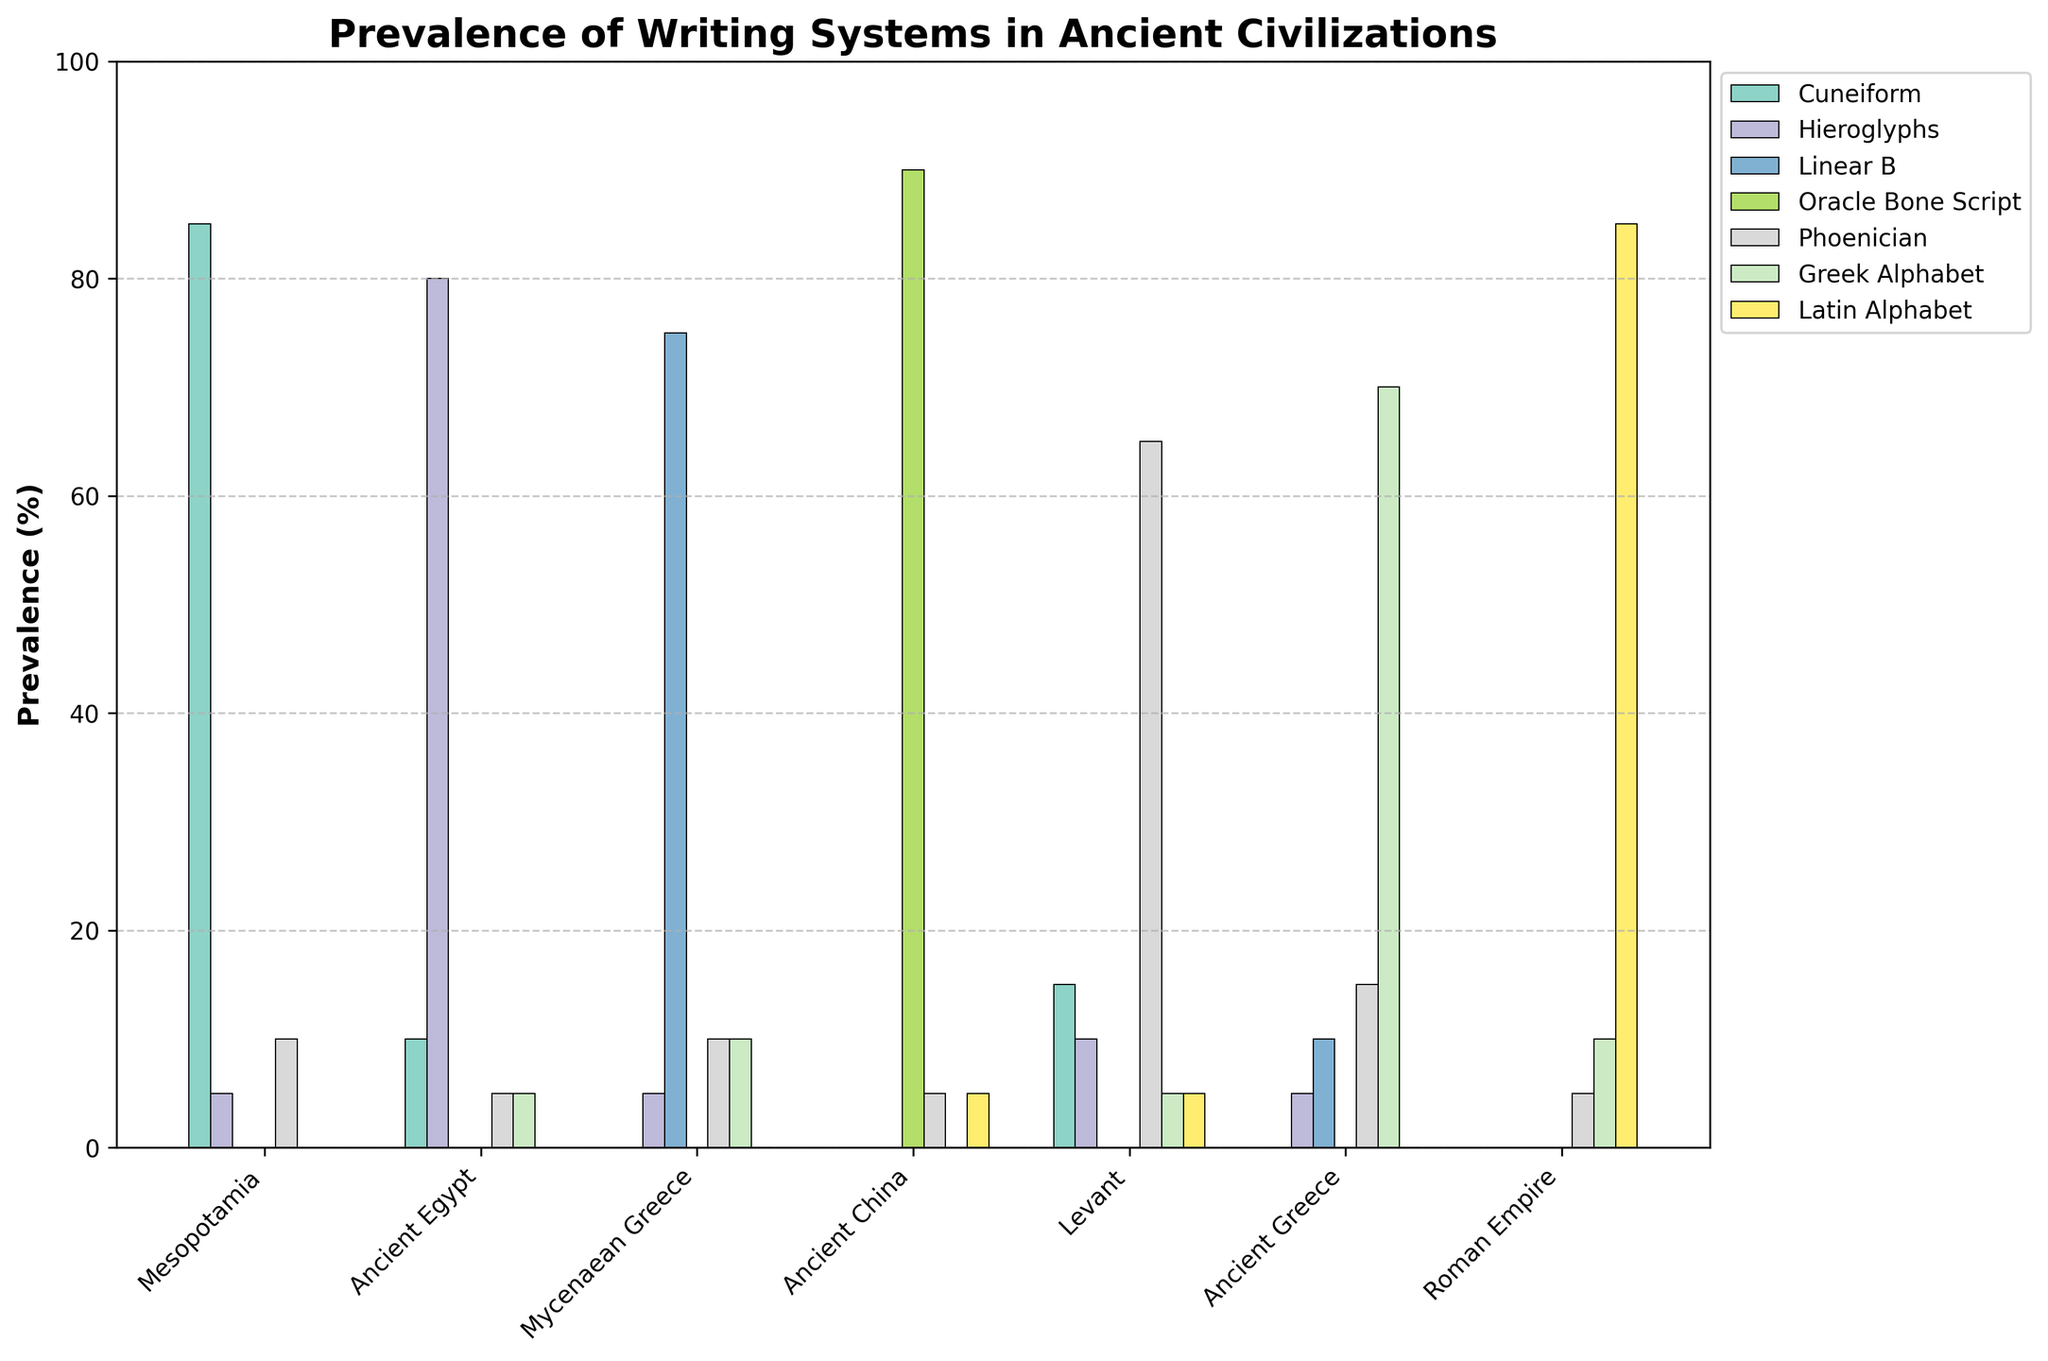What's the most prevalent writing system in Ancient Egypt? The figure shows the prevalence of various writing systems in Ancient Egypt by the height and color of the bars. The tallest bar for Ancient Egypt, which represents the highest prevalence, is Hieroglyphs.
Answer: Hieroglyphs Which regions have shared the use of the Greek Alphabet? The figure indicates the prevalence of writing systems by color-coded bars. The Greek Alphabet is used in Ancient Egypt, Mycenaean Greece, Ancient Greece, and the Roman Empire, as indicated by colored bars for these regions.
Answer: Ancient Egypt, Mycenaean Greece, Ancient Greece, Roman Empire What is the combined prevalence of Cuneiform and Phoenician in Mesopotamia? In the figure, the Cuneiform prevalence in Mesopotamia is 85, and Phoenician is 10. Adding these, we get 85 + 10 = 95.
Answer: 95 Which region shows the highest prevalence of the Oracle Bone Script? The figure shows the heights of bars representing different writing systems in each region. The Oracle Bone Script has the highest bar in Ancient China, indicating the highest prevalence there.
Answer: Ancient China Compare the prevalence of Linear B in Mycenaean Greece and Ancient Greece. In which region is it more prevalent? From the figure, the height of the bar for Linear B in Mycenaean Greece is 75, and in Ancient Greece, it is 10. Therefore, Linear B is more prevalent in Mycenaean Greece.
Answer: Mycenaean Greece In which regions does the Latin Alphabet have any presence? The figure shows bars representing the prevalence of the Latin Alphabet in different regions. Only the Roman Empire has a non-zero value (85) for the Latin Alphabet.
Answer: Roman Empire What is the average prevalence of the Greek Alphabet in Mycenaean Greece and Ancient Greece? The figure shows the prevalence of the Greek Alphabet in Mycenaean Greece is 10, and in Ancient Greece is 70. The average is calculated by (10 + 70) / 2 = 40.
Answer: 40 Which writing system appears in all regions? Observing the figure, the Greek Alphabet is the only writing system with bars representing its prevalence in every region listed.
Answer: Greek Alphabet 